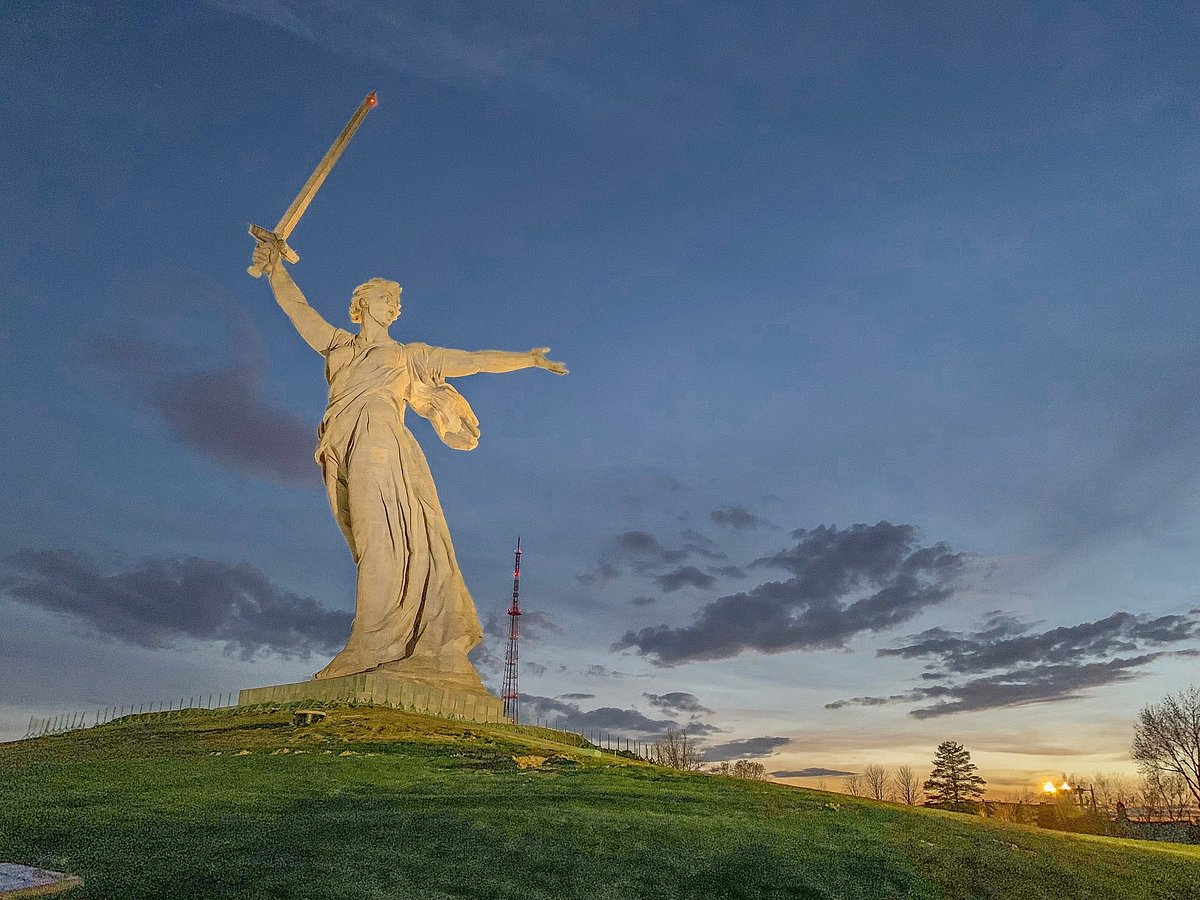Can you describe the atmosphere and surroundings in the image? The atmosphere in the image is serene yet awe-inspiring, with the sky painted in the soft, tranquil hues of twilight, merging shades of orange and blue. The expansive green lawn at the base of the statue suggests a peaceful and lush environment, enriched by the natural beauty of scattered trees. A red and white radio tower in the background adds a touch of modernity to this historical setting. The overall composition, with the statue viewed from a low angle, enhances the sense of grandeur and magnificence. The fading light of day infuses a calm, reflective mood, contrasting the monument's powerful and heroic symbolism. 